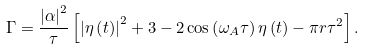<formula> <loc_0><loc_0><loc_500><loc_500>\Gamma = \frac { \left | \alpha \right | ^ { 2 } } { \tau } \left [ \left | \eta \left ( t \right ) \right | ^ { 2 } + 3 - 2 \cos \left ( \omega _ { A } \tau \right ) \eta \left ( t \right ) - \pi r \tau ^ { 2 } \right ] .</formula> 